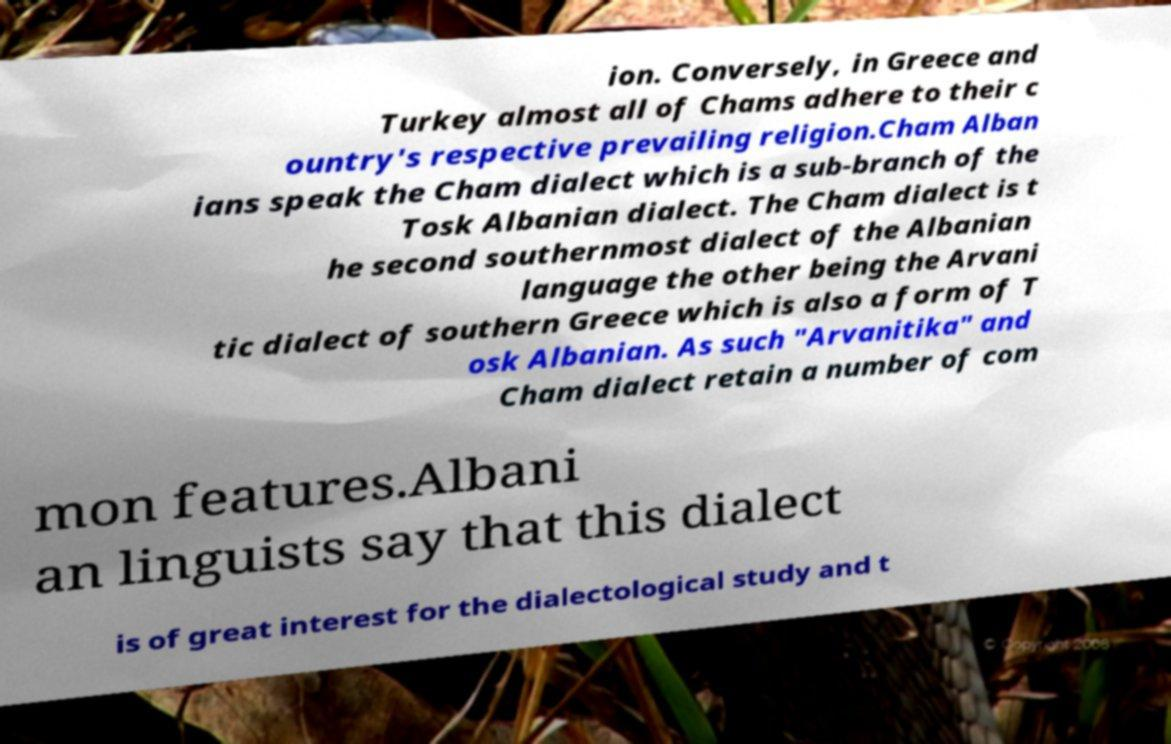For documentation purposes, I need the text within this image transcribed. Could you provide that? ion. Conversely, in Greece and Turkey almost all of Chams adhere to their c ountry's respective prevailing religion.Cham Alban ians speak the Cham dialect which is a sub-branch of the Tosk Albanian dialect. The Cham dialect is t he second southernmost dialect of the Albanian language the other being the Arvani tic dialect of southern Greece which is also a form of T osk Albanian. As such "Arvanitika" and Cham dialect retain a number of com mon features.Albani an linguists say that this dialect is of great interest for the dialectological study and t 